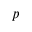<formula> <loc_0><loc_0><loc_500><loc_500>p</formula> 